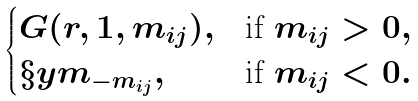<formula> <loc_0><loc_0><loc_500><loc_500>\begin{cases} G ( r , 1 , m _ { i j } ) , & \text {if } m _ { i j } > 0 , \\ \S y m _ { - m _ { i j } } , & \text {if } m _ { i j } < 0 . \end{cases}</formula> 